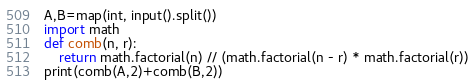Convert code to text. <code><loc_0><loc_0><loc_500><loc_500><_Python_>A,B=map(int, input().split())
import math
def comb(n, r):
    return math.factorial(n) // (math.factorial(n - r) * math.factorial(r))
print(comb(A,2)+comb(B,2))</code> 